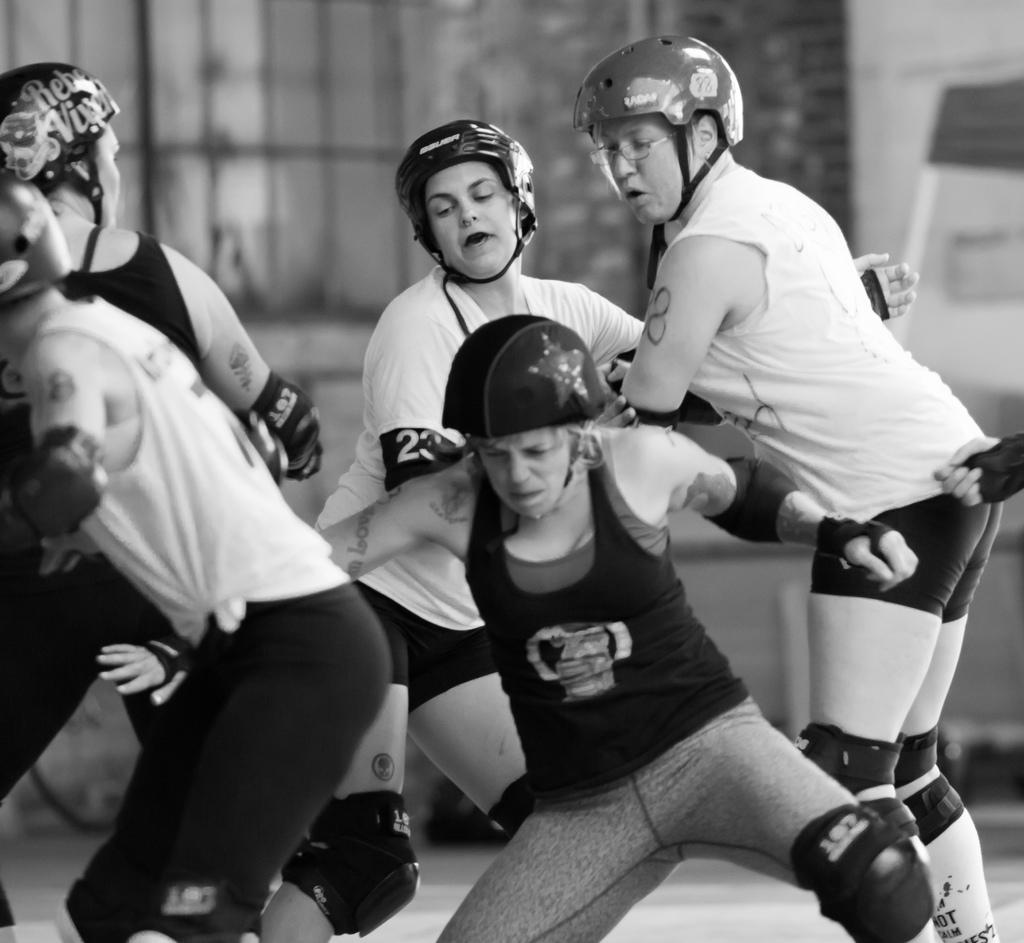What is the color scheme of the image? The image is black and white. What are the people in the image wearing? The people in the image are wearing helmets. What can be seen beneath the people in the image? The ground is visible in the image. How would you describe the background of the image? The background is blurred. What type of milk can be seen in the image? There is no milk present in the image. How many clovers are visible in the image? There are no clovers visible in the image. 